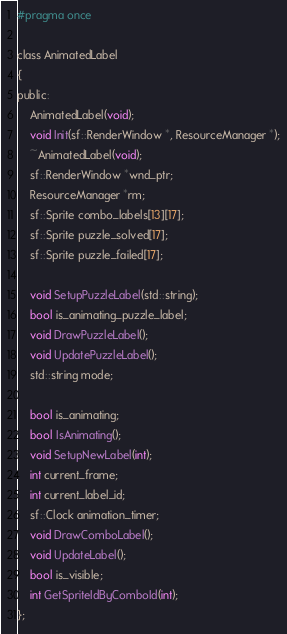Convert code to text. <code><loc_0><loc_0><loc_500><loc_500><_C_>#pragma once

class AnimatedLabel
{
public:
	AnimatedLabel(void);
	void Init(sf::RenderWindow *, ResourceManager *);
	~AnimatedLabel(void);
	sf::RenderWindow *wnd_ptr;
	ResourceManager *rm;
	sf::Sprite combo_labels[13][17];
	sf::Sprite puzzle_solved[17];
	sf::Sprite puzzle_failed[17];

	void SetupPuzzleLabel(std::string);
	bool is_animating_puzzle_label;
	void DrawPuzzleLabel();
	void UpdatePuzzleLabel();
	std::string mode;

	bool is_animating;
	bool IsAnimating();
	void SetupNewLabel(int);
	int current_frame;
	int current_label_id;
	sf::Clock animation_timer;
	void DrawComboLabel();
	void UpdateLabel();
	bool is_visible;
	int GetSpriteIdByComboId(int);
};
</code> 